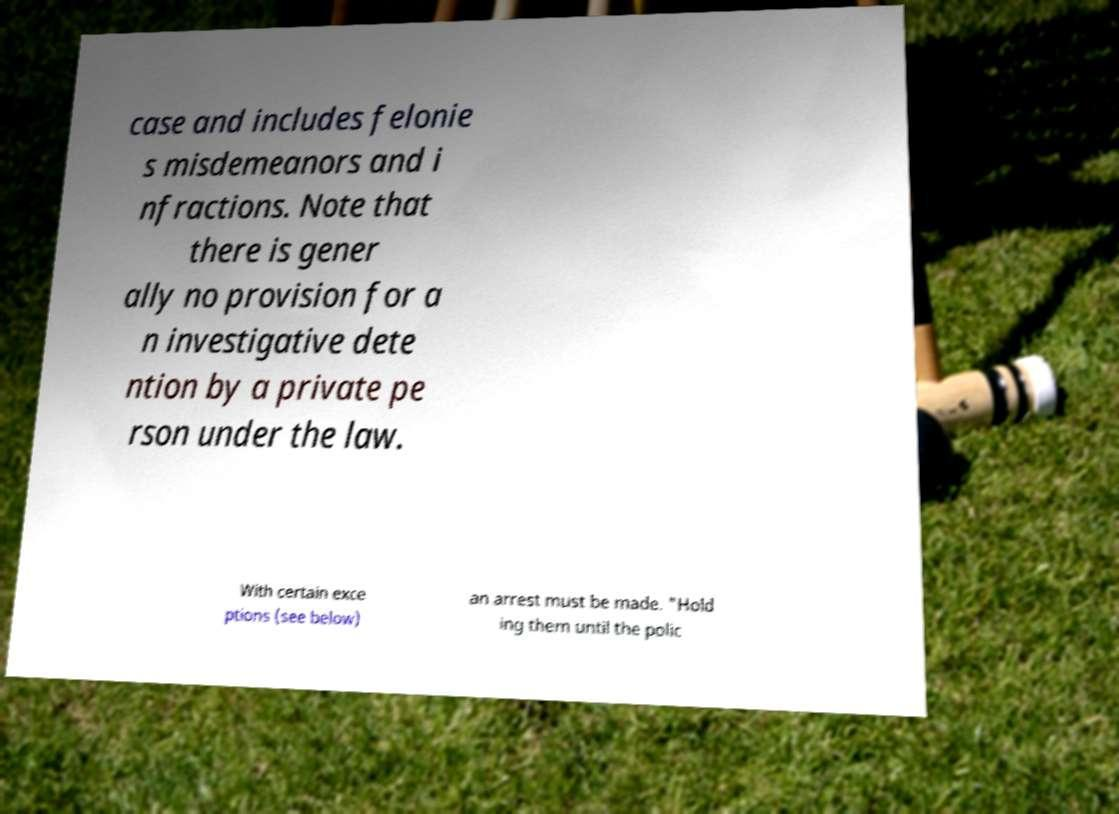Could you extract and type out the text from this image? case and includes felonie s misdemeanors and i nfractions. Note that there is gener ally no provision for a n investigative dete ntion by a private pe rson under the law. With certain exce ptions (see below) an arrest must be made. "Hold ing them until the polic 